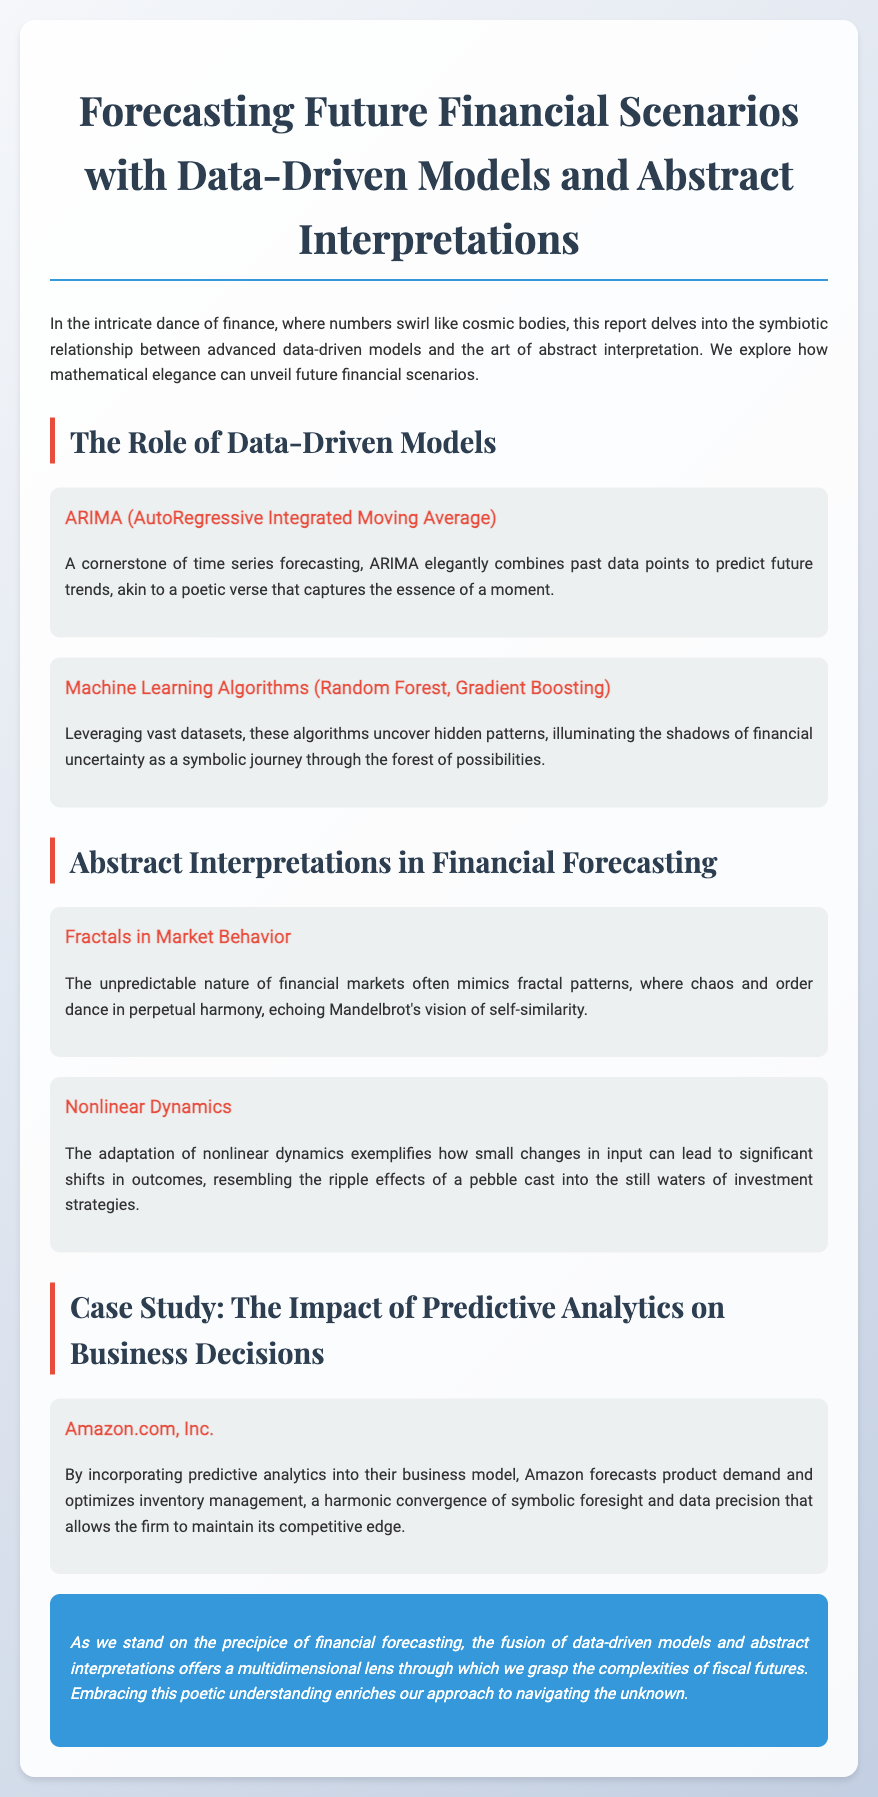What is the title of the report? The title of the report is stated at the top of the document, "Forecasting Future Financial Scenarios with Data-Driven Models and Abstract Interpretations."
Answer: Forecasting Future Financial Scenarios with Data-Driven Models and Abstract Interpretations What methodology is described as a cornerstone of time series forecasting? The document mentions ARIMA as a cornerstone methodology for time series forecasting.
Answer: ARIMA What does the document link machine learning algorithms to? The text explores how machine learning algorithms uncover hidden patterns, illuminating complexities in financial data.
Answer: Complexities in financial data Which company is used as a case study in the report? The case study featured in the report is about Amazon.com, Inc.
Answer: Amazon.com, Inc What abstract concept is associated with market behavior in the report? The report discusses fractals as an abstract concept linked with unpredictable market behavior.
Answer: Fractals How does the report describe nonlinear dynamics? The report states that nonlinear dynamics illustrate how small changes can lead to significant outcome shifts, symbolizing the ripple effect.
Answer: Ripple effect What color is used for the conclusion section in the report? The conclusion section is highlighted in blue, specifically the color code for azure, creating a visually distinct area.
Answer: Blue 